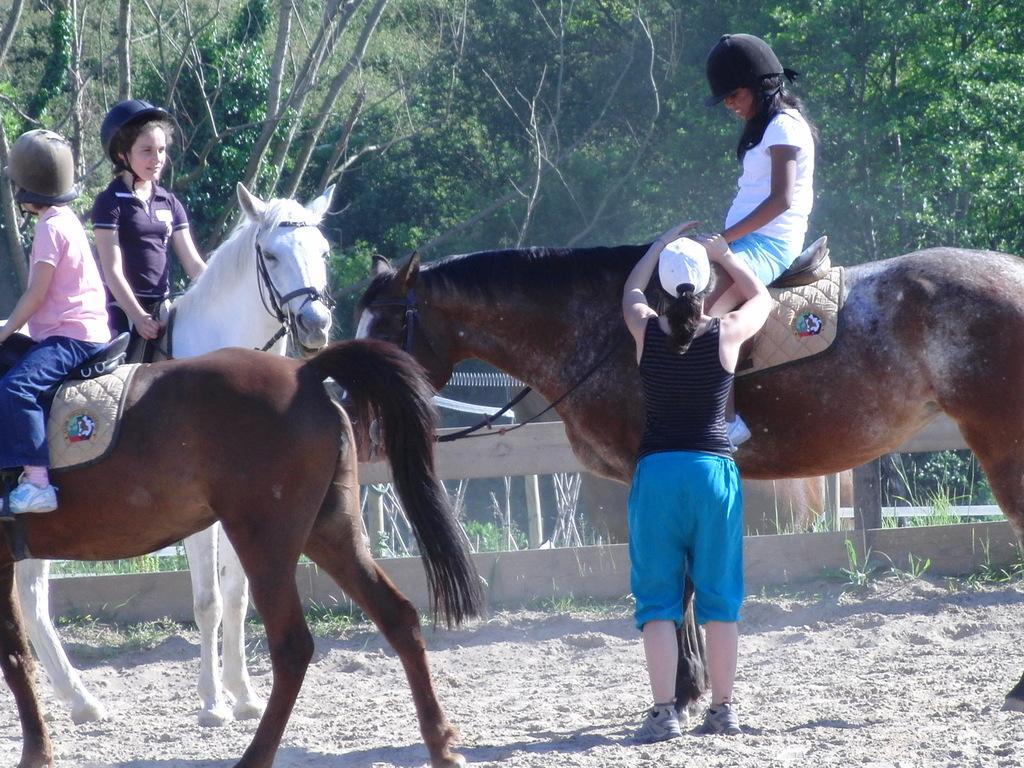Could you give a brief overview of what you see in this image? This picture shows three girls riding horses and woman standing and trees around 